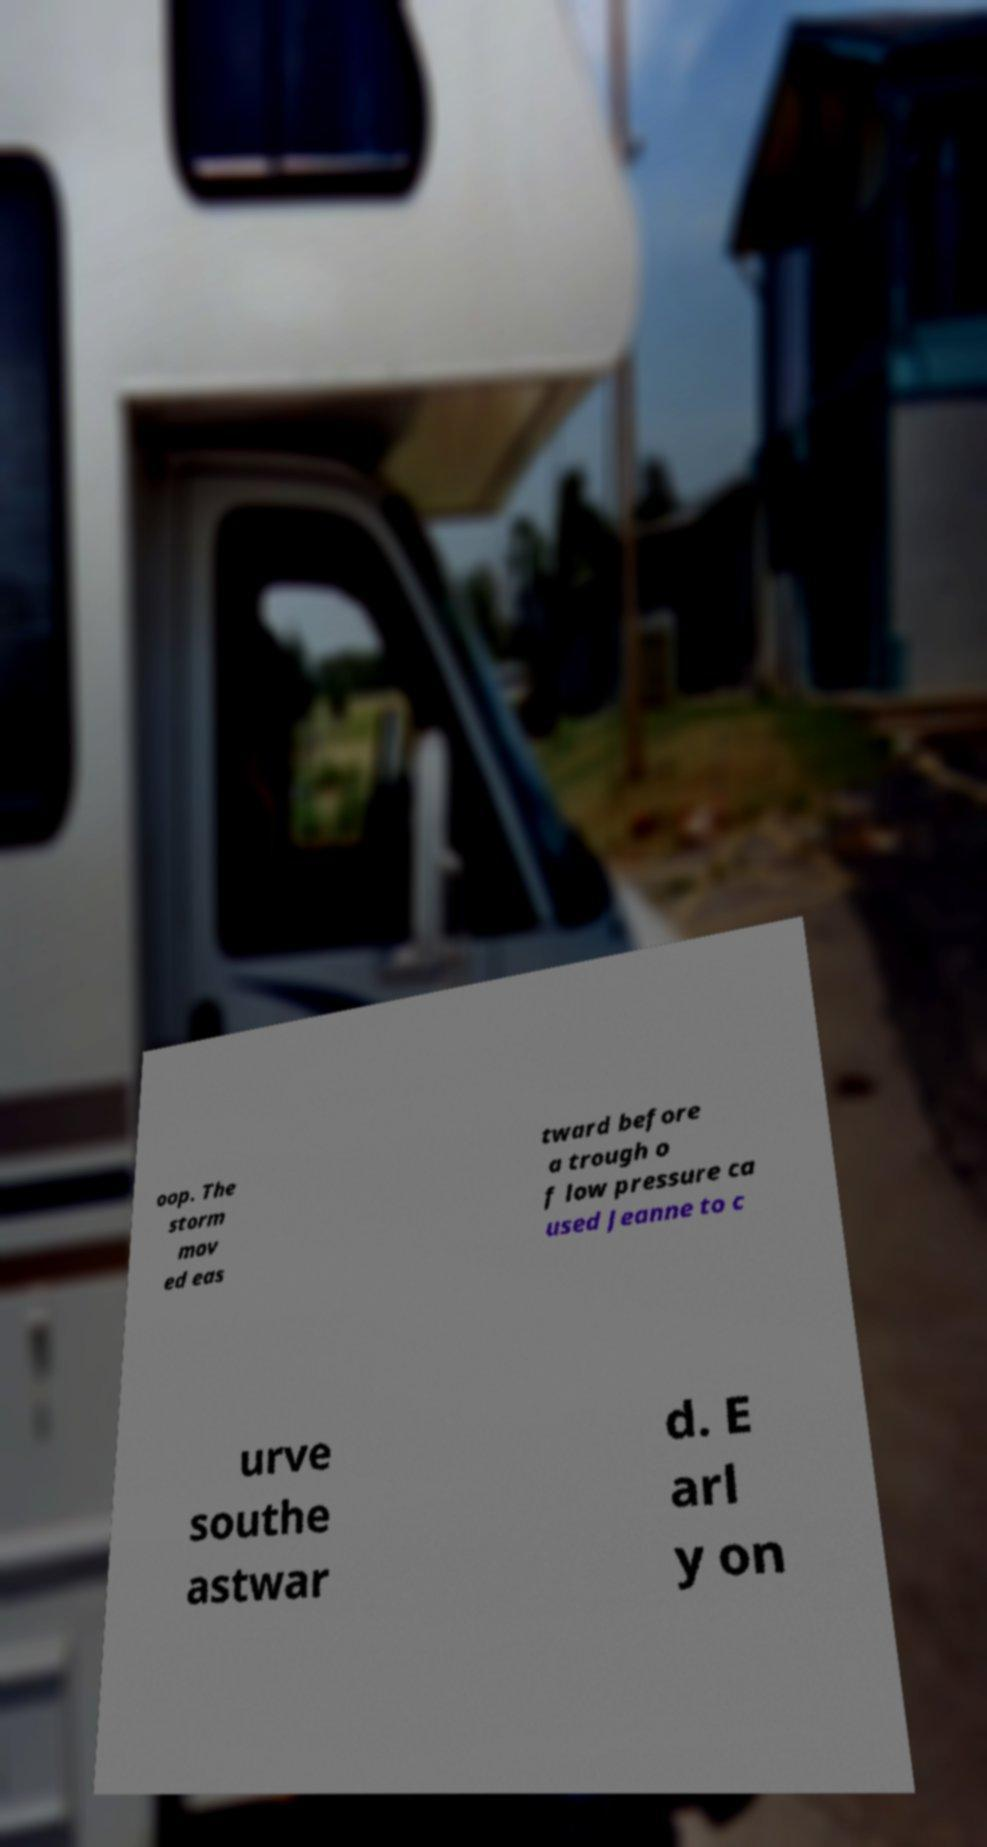There's text embedded in this image that I need extracted. Can you transcribe it verbatim? oop. The storm mov ed eas tward before a trough o f low pressure ca used Jeanne to c urve southe astwar d. E arl y on 